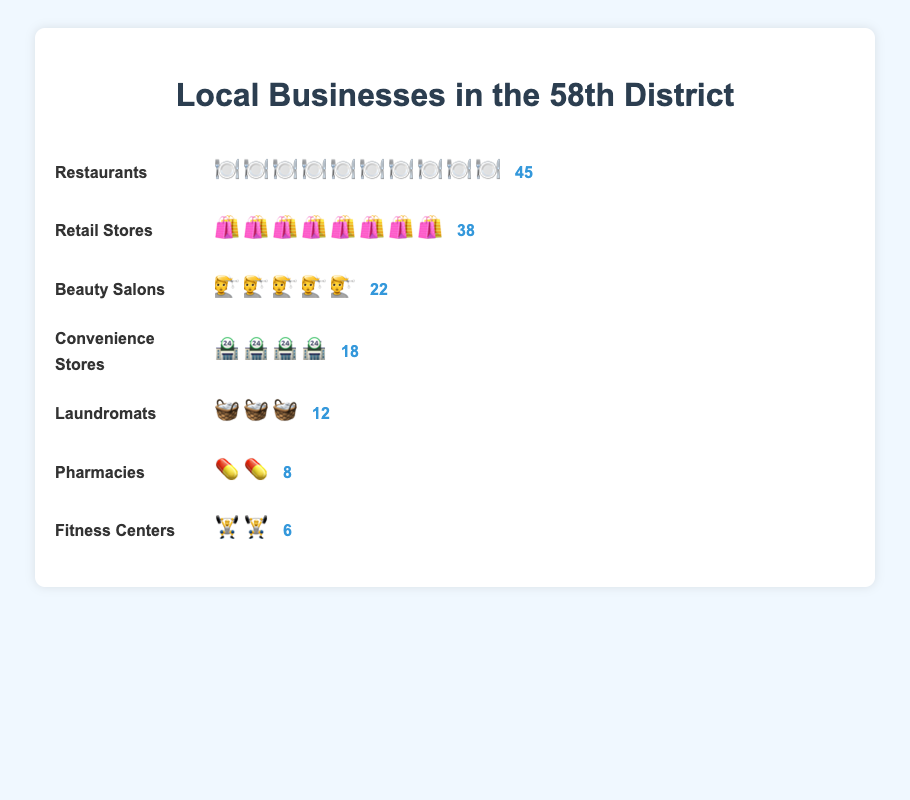How many types of local businesses are shown in the figure? There are labels for each type of local business (e.g., Restaurants, Retail Stores, Beauty Salons, etc.) listed vertically in the chart. Counting all these categories gives us the total number of business types.
Answer: 7 Which industry has the highest number of businesses? By examining the counts next to each industry name, the 'Restaurants' category stands out with the highest count of business icons (🍽️), totaling 45.
Answer: Restaurants What is the total number of retail stores and beauty salons combined? The 'Retail Stores' have 38 businesses and 'Beauty Salons' have 22. Adding these together: 38 + 22 = 60.
Answer: 60 Which types of businesses have fewer than 20 shops? Checking the counts for each type, 'Beauty Salons' have 22, 'Convenience Stores' have 18, 'Laundromats' have 12, 'Pharmacies' have 8, and 'Fitness Centers' have 6. Therefore, ‘Convenience Stores,’ ‘Laundromats,’ ‘Pharmacies,’ and ‘Fitness Centers’ all have counts under 20.
Answer: Convenience Stores, Laundromats, Pharmacies, Fitness Centers How many more restaurants are there than laundromats? The chart shows 45 restaurants and 12 laundromats. Subtracting these gives: 45 - 12 = 33 more restaurants than laundromats.
Answer: 33 What is the second most common type of business? Looking at the counts next to each category, the 'Restaurants' are the highest at 45, and the next highest count is 'Retail Stores' with 38.
Answer: Retail Stores Are there more pharmacies or fitness centers? By comparing the counts, 'Pharmacies' have 8 shops, whereas 'Fitness Centers' have 6. So, pharmacies are more common.
Answer: Pharmacies What percent of the total businesses are fitness centers? Summing up all counts: 45 + 38 + 22 + 18 + 12 + 8 + 6 = 149. Fitness centers have 6 businesses. Hence, the percentage is (6 / 149) * 100 ≈ 4.03%.
Answer: 4.03% What is the least common type of business? Checking the counts for each business type, 'Fitness Centers' have the lowest count with 6.
Answer: Fitness Centers Which two types of businesses together make up more than 50% of the total count? Summing all counts gives 149. To find more than 50%, calculate 149/2 ≈ 74.5. 'Restaurants' have 45 and 'Retail Stores' have 38, adding these gives 45 + 38 = 83, which is more than 74.5. So Restaurants and Retail Stores combined make up more than 50%.
Answer: Restaurants and Retail Stores 